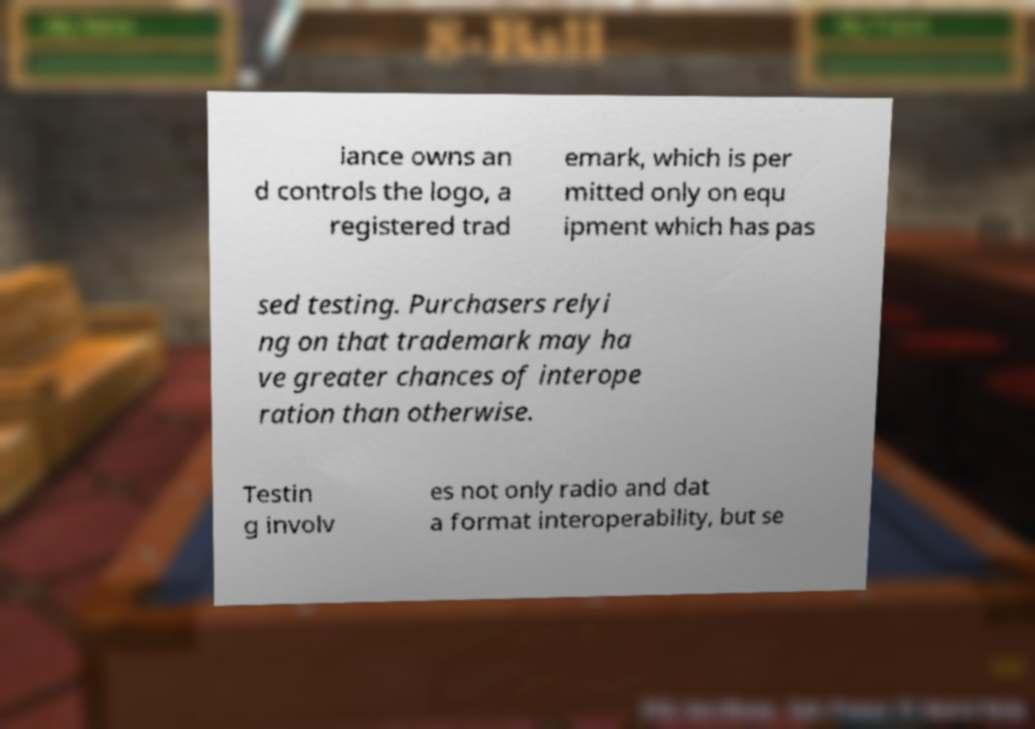There's text embedded in this image that I need extracted. Can you transcribe it verbatim? iance owns an d controls the logo, a registered trad emark, which is per mitted only on equ ipment which has pas sed testing. Purchasers relyi ng on that trademark may ha ve greater chances of interope ration than otherwise. Testin g involv es not only radio and dat a format interoperability, but se 